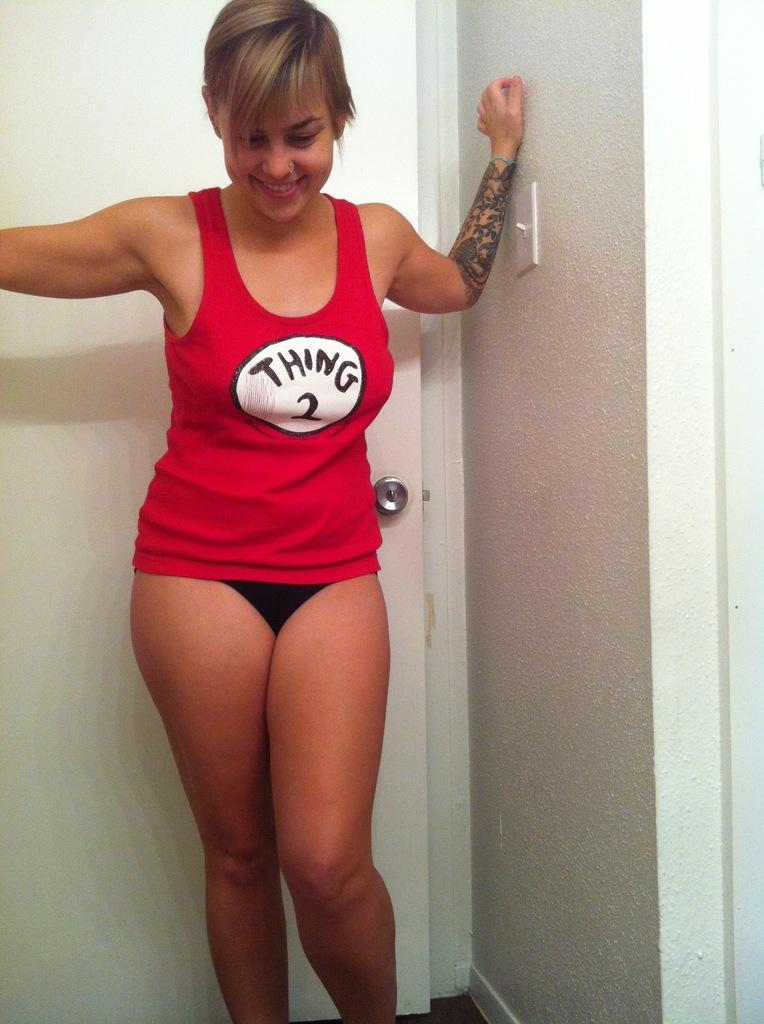<image>
Summarize the visual content of the image. A girl wears a red tank top with Thing 2 on the front. 